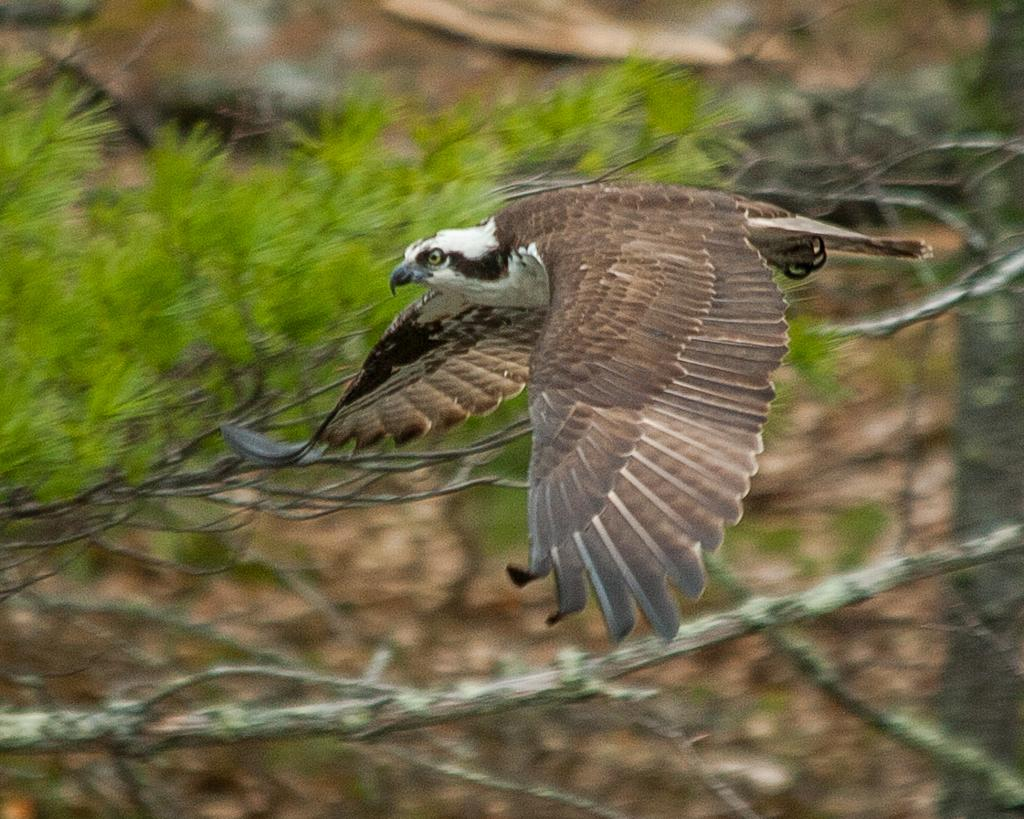What animal is in the foreground of the image? There is an eagle in the foreground of the image. What is the eagle doing in the image? The eagle is in the air. What can be seen in the background of the image? There is a tree in the background of the image. How is the tree depicted in the image? The tree appears blurred. How many skateboards are visible in the image? There are no skateboards present in the image; it features an eagle in the air and a blurred tree in the background. 